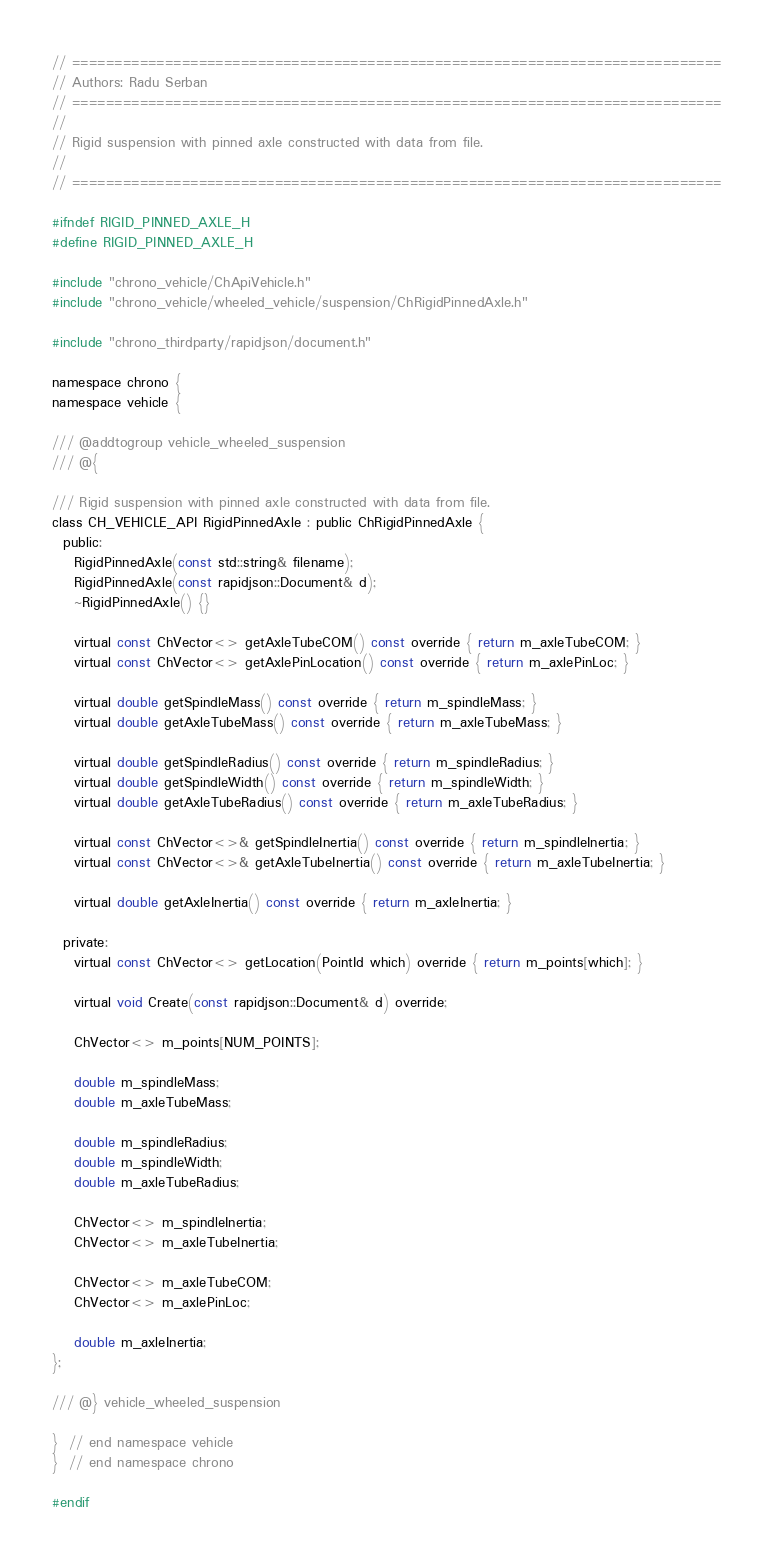Convert code to text. <code><loc_0><loc_0><loc_500><loc_500><_C_>// =============================================================================
// Authors: Radu Serban
// =============================================================================
//
// Rigid suspension with pinned axle constructed with data from file.
//
// =============================================================================

#ifndef RIGID_PINNED_AXLE_H
#define RIGID_PINNED_AXLE_H

#include "chrono_vehicle/ChApiVehicle.h"
#include "chrono_vehicle/wheeled_vehicle/suspension/ChRigidPinnedAxle.h"

#include "chrono_thirdparty/rapidjson/document.h"

namespace chrono {
namespace vehicle {

/// @addtogroup vehicle_wheeled_suspension
/// @{

/// Rigid suspension with pinned axle constructed with data from file.
class CH_VEHICLE_API RigidPinnedAxle : public ChRigidPinnedAxle {
  public:
    RigidPinnedAxle(const std::string& filename);
    RigidPinnedAxle(const rapidjson::Document& d);
    ~RigidPinnedAxle() {}

    virtual const ChVector<> getAxleTubeCOM() const override { return m_axleTubeCOM; }
    virtual const ChVector<> getAxlePinLocation() const override { return m_axlePinLoc; }

    virtual double getSpindleMass() const override { return m_spindleMass; }
    virtual double getAxleTubeMass() const override { return m_axleTubeMass; }

    virtual double getSpindleRadius() const override { return m_spindleRadius; }
    virtual double getSpindleWidth() const override { return m_spindleWidth; }
    virtual double getAxleTubeRadius() const override { return m_axleTubeRadius; }

    virtual const ChVector<>& getSpindleInertia() const override { return m_spindleInertia; }
    virtual const ChVector<>& getAxleTubeInertia() const override { return m_axleTubeInertia; }

    virtual double getAxleInertia() const override { return m_axleInertia; }

  private:
    virtual const ChVector<> getLocation(PointId which) override { return m_points[which]; }

    virtual void Create(const rapidjson::Document& d) override;

    ChVector<> m_points[NUM_POINTS];

    double m_spindleMass;
    double m_axleTubeMass;

    double m_spindleRadius;
    double m_spindleWidth;
    double m_axleTubeRadius;

    ChVector<> m_spindleInertia;
    ChVector<> m_axleTubeInertia;

    ChVector<> m_axleTubeCOM;
    ChVector<> m_axlePinLoc;

    double m_axleInertia;
};

/// @} vehicle_wheeled_suspension

}  // end namespace vehicle
}  // end namespace chrono

#endif
</code> 